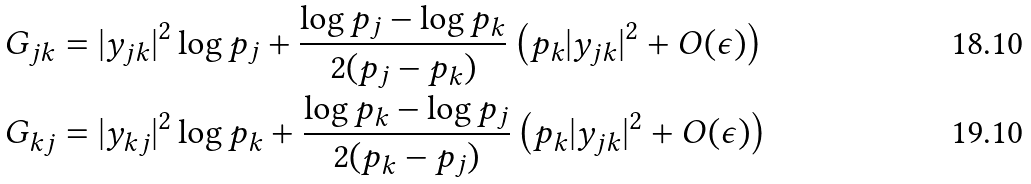<formula> <loc_0><loc_0><loc_500><loc_500>G _ { j k } & = | y _ { j k } | ^ { 2 } \log p _ { j } + \frac { \log p _ { j } - \log p _ { k } } { 2 ( p _ { j } - p _ { k } ) } \left ( p _ { k } | y _ { j k } | ^ { 2 } + O ( \epsilon ) \right ) \\ G _ { k j } & = | y _ { k j } | ^ { 2 } \log p _ { k } + \frac { \log p _ { k } - \log p _ { j } } { 2 ( p _ { k } - p _ { j } ) } \left ( p _ { k } | y _ { j k } | ^ { 2 } + O ( \epsilon ) \right )</formula> 